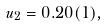<formula> <loc_0><loc_0><loc_500><loc_500>u _ { 2 } = 0 . 2 0 ( 1 ) ,</formula> 